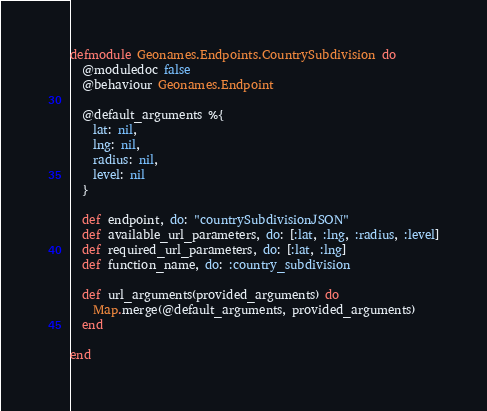Convert code to text. <code><loc_0><loc_0><loc_500><loc_500><_Elixir_>defmodule Geonames.Endpoints.CountrySubdivision do
  @moduledoc false
  @behaviour Geonames.Endpoint

  @default_arguments %{
    lat: nil,
    lng: nil,
    radius: nil,
    level: nil
  }

  def endpoint, do: "countrySubdivisionJSON"
  def available_url_parameters, do: [:lat, :lng, :radius, :level]
  def required_url_parameters, do: [:lat, :lng]
  def function_name, do: :country_subdivision

  def url_arguments(provided_arguments) do
    Map.merge(@default_arguments, provided_arguments)
  end

end
</code> 